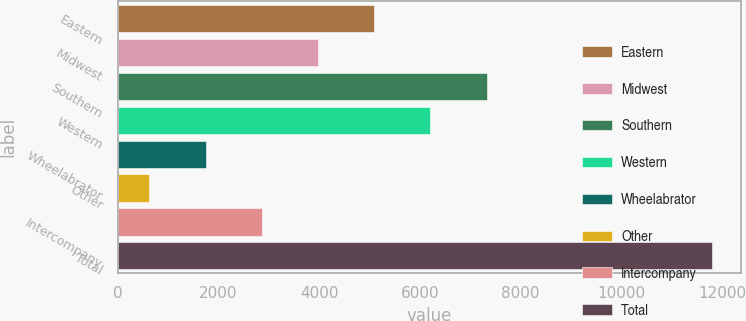<chart> <loc_0><loc_0><loc_500><loc_500><bar_chart><fcel>Eastern<fcel>Midwest<fcel>Southern<fcel>Western<fcel>Wheelabrator<fcel>Other<fcel>Intercompany<fcel>Total<nl><fcel>5093.2<fcel>3976.9<fcel>7325.8<fcel>6209.5<fcel>1744.3<fcel>628<fcel>2860.6<fcel>11791<nl></chart> 